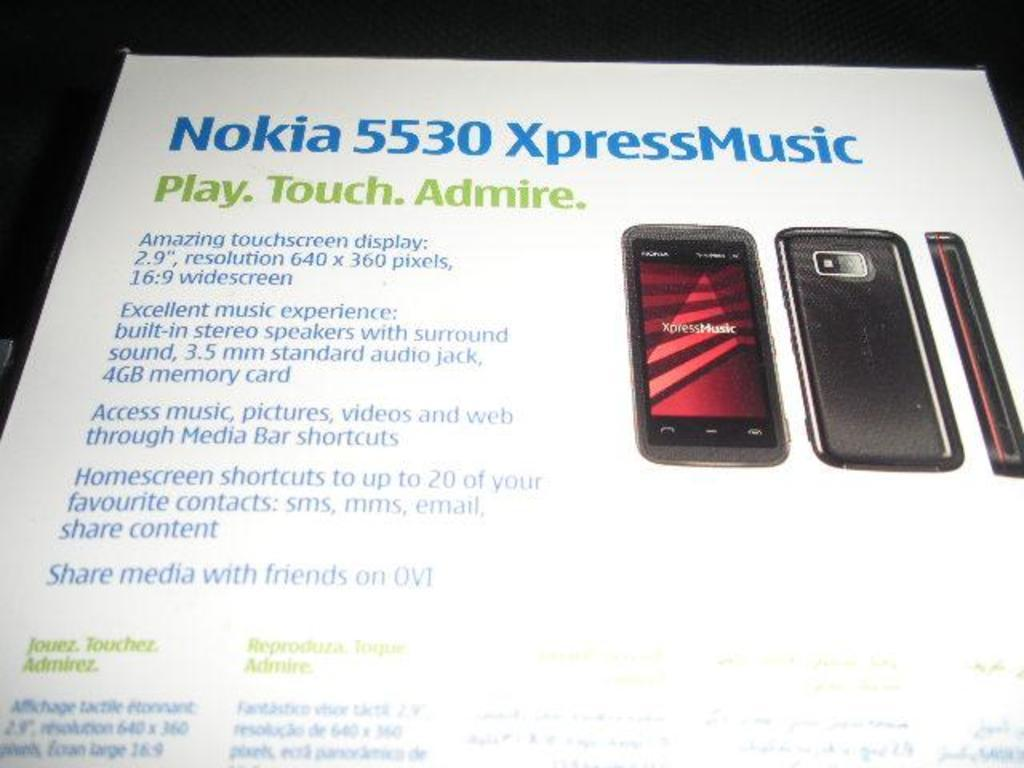<image>
Relay a brief, clear account of the picture shown. A white box contains a Nokia 5530 XpressMusic personal device. 